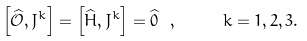<formula> <loc_0><loc_0><loc_500><loc_500>\left [ \widehat { \mathcal { O } } , J ^ { k } \right ] = \left [ \widehat { H } , J ^ { k } \right ] = \widehat { 0 } \ , \quad \ k = 1 , 2 , 3 .</formula> 